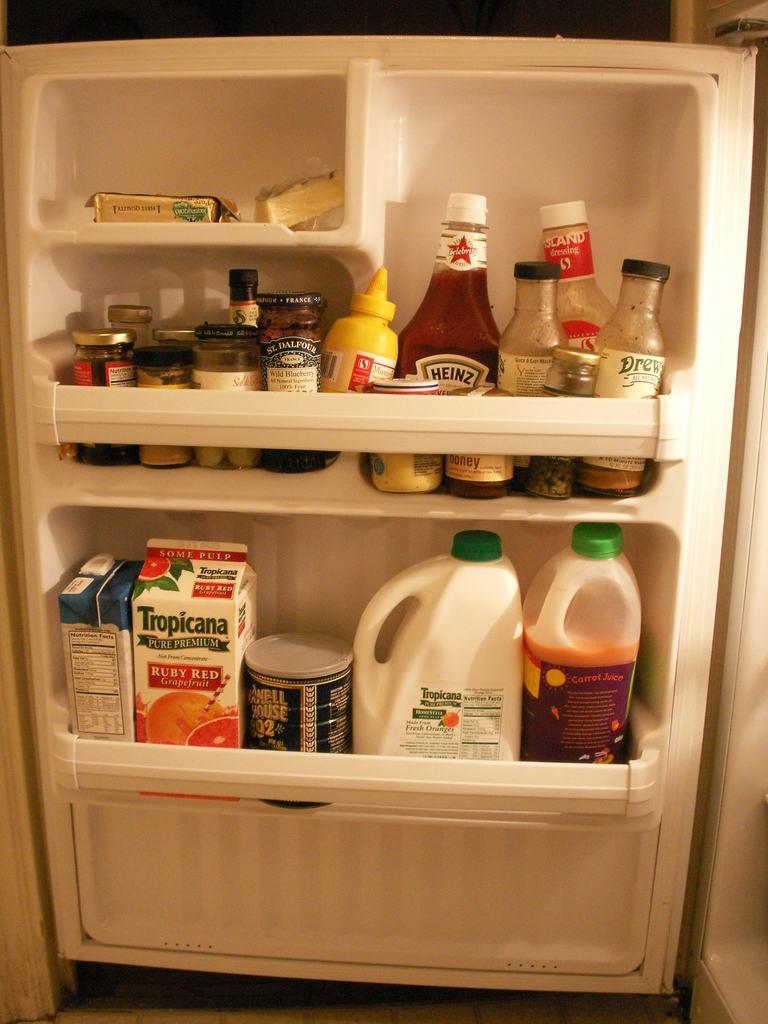<image>
Give a short and clear explanation of the subsequent image. A container of Ruby Red Grapefruit juice is in the door of the refrigerator. 